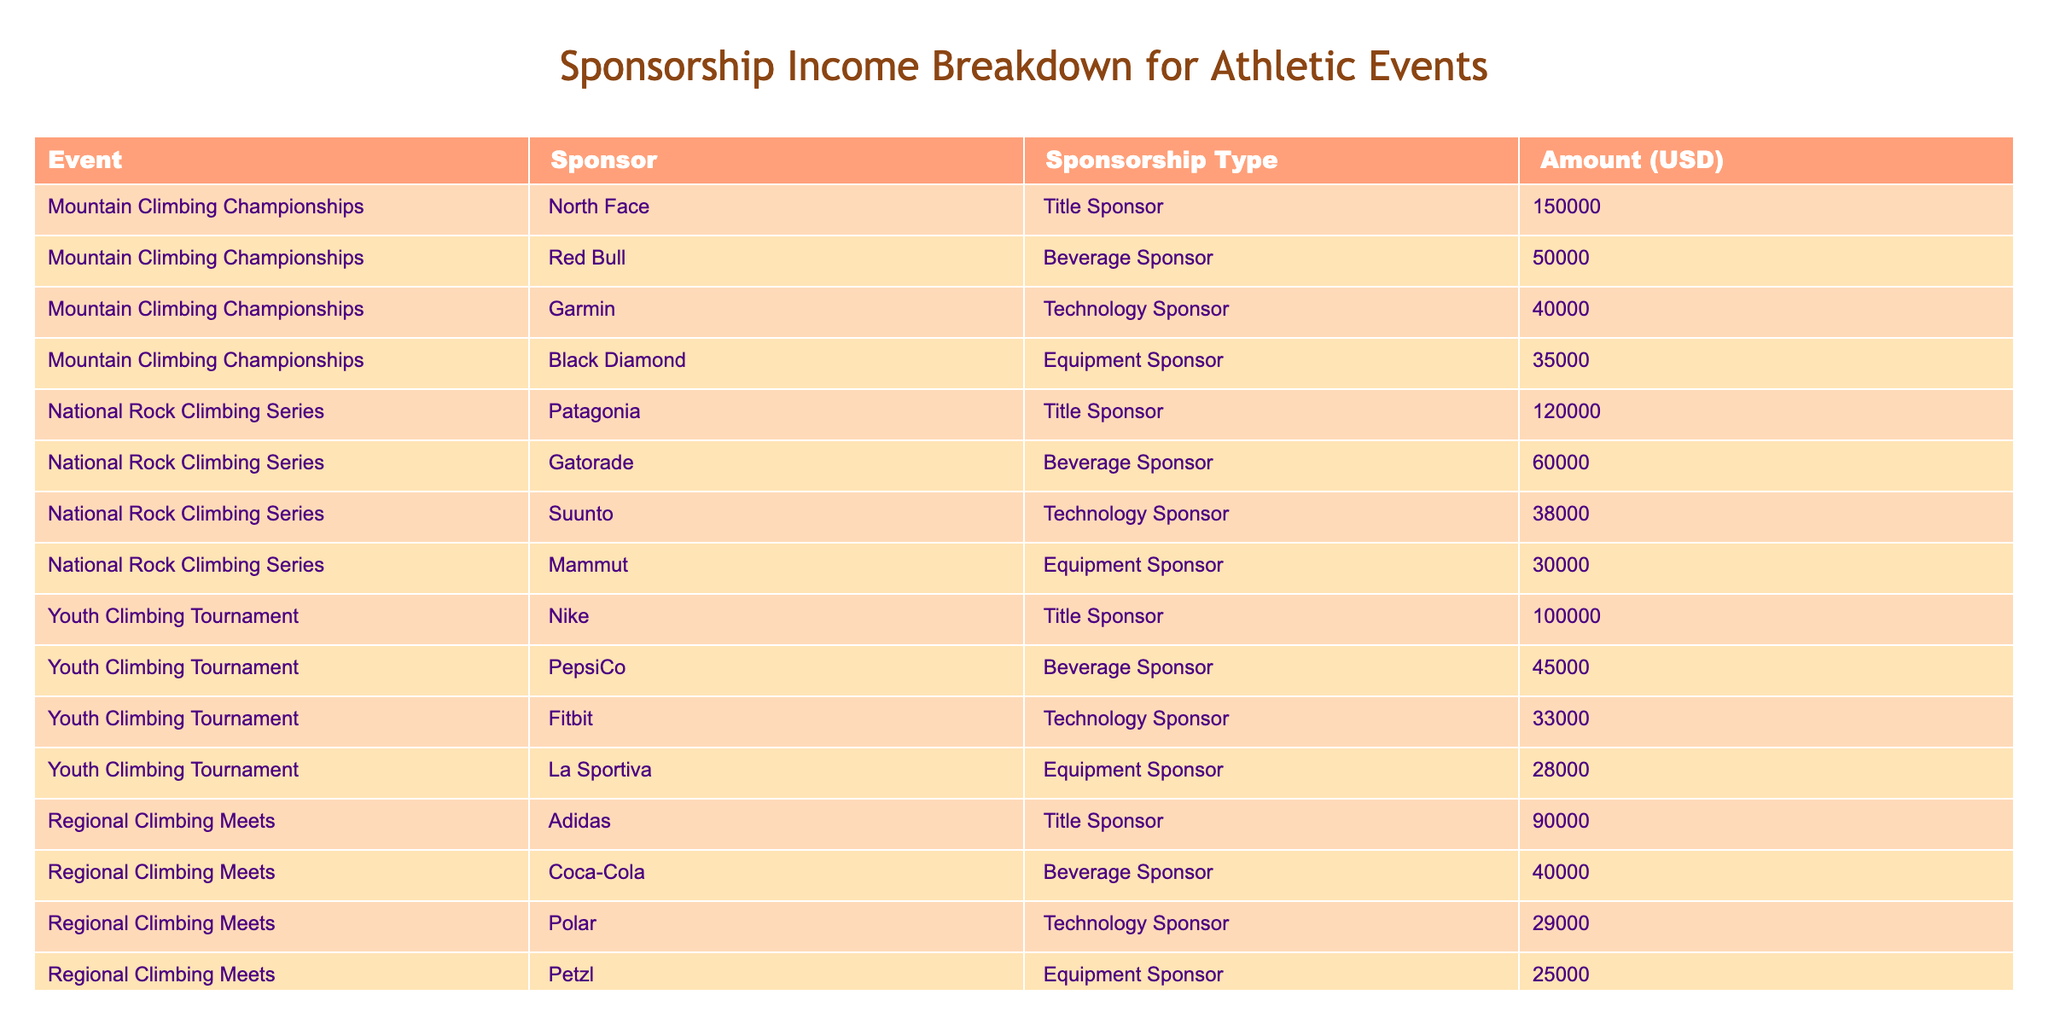What is the total sponsorship amount for the Mountain Climbing Championships? To find the total sponsorship amount for the Mountain Climbing Championships, we need to sum the amounts from all sponsors associated with this event: 150000 (North Face) + 50000 (Red Bull) + 40000 (Garmin) + 35000 (Black Diamond) = 280000.
Answer: 280000 Which sponsor contributed the highest amount for the National Rock Climbing Series? Looking at the National Rock Climbing Series, we have the following amounts: 120000 (Patagonia), 60000 (Gatorade), 38000 (Suunto), and 30000 (Mammut). The highest amount is 120000 from Patagonia.
Answer: Patagonia Is there a Technology Sponsor for the Youth Climbing Tournament? Checking the table, we see that Fitbit is listed as a Technology Sponsor for the Youth Climbing Tournament with an amount of 33000. Thus, there is indeed a Technology Sponsor.
Answer: Yes What is the average sponsorship amount for the Regional Climbing Meets? For the Regional Climbing Meets, we have the following amounts: 90000 (Adidas), 40000 (Coca-Cola), 29000 (Polar), and 25000 (Petzl). To find the average, we add these amounts: 90000 + 40000 + 29000 + 25000 = 184000. There are 4 sponsors, so the average is 184000 / 4 = 46000.
Answer: 46000 Which event received the least total sponsorship income among all listed events? We can calculate the total sponsorship for each event: Mountain Climbing Championships = 280000, National Rock Climbing Series = 238000, Youth Climbing Tournament = 178000, and Regional Climbing Meets = 184000. The least total is 178000 for the Youth Climbing Tournament.
Answer: Youth Climbing Tournament 